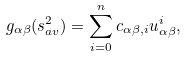Convert formula to latex. <formula><loc_0><loc_0><loc_500><loc_500>g _ { \alpha \beta } ( s _ { a v } ^ { 2 } ) = \sum _ { i = 0 } ^ { n } c _ { \alpha \beta , i } u _ { \alpha \beta } ^ { i } ,</formula> 